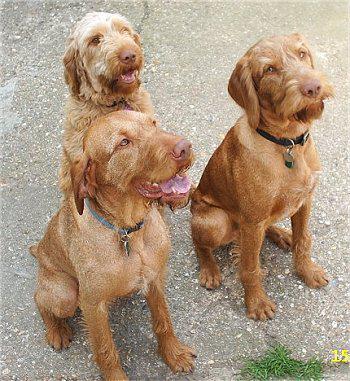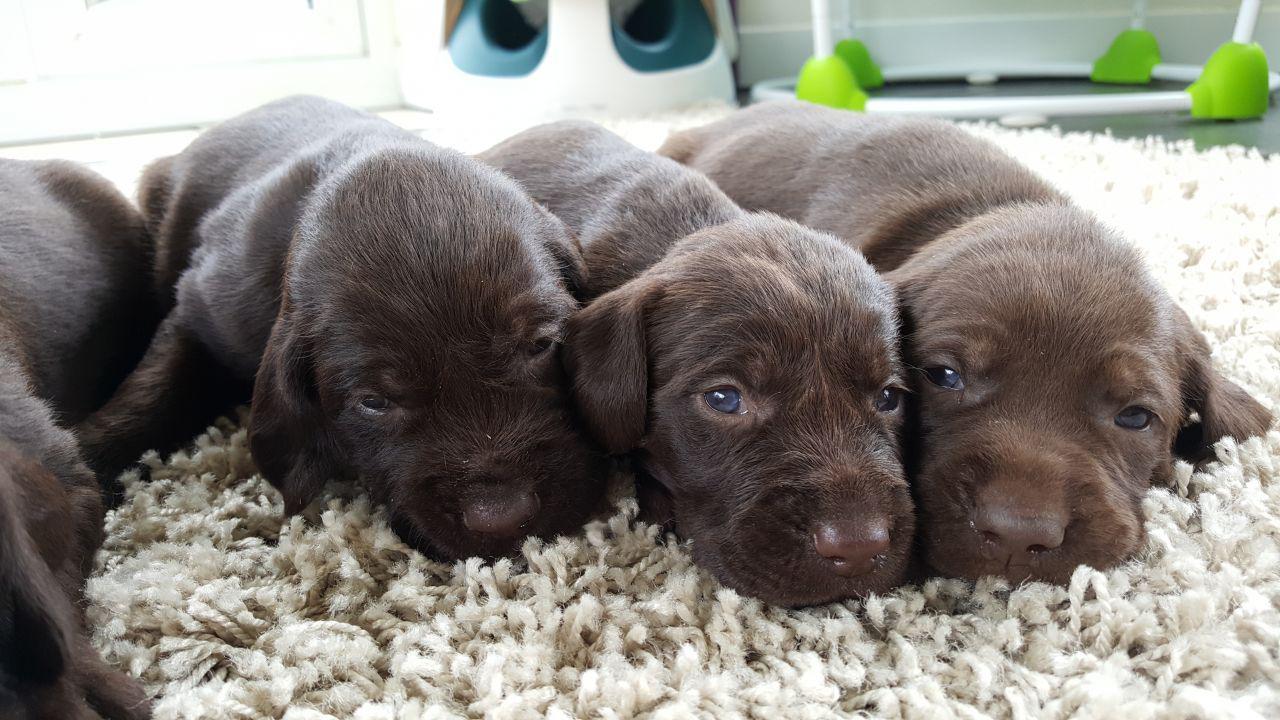The first image is the image on the left, the second image is the image on the right. Examine the images to the left and right. Is the description "The right image contains exactly one dog." accurate? Answer yes or no. No. The first image is the image on the left, the second image is the image on the right. Analyze the images presented: Is the assertion "The combined images include one reddish-brown reclining dog and at least two spaniels with mostly white bodies and darker face markings." valid? Answer yes or no. No. 